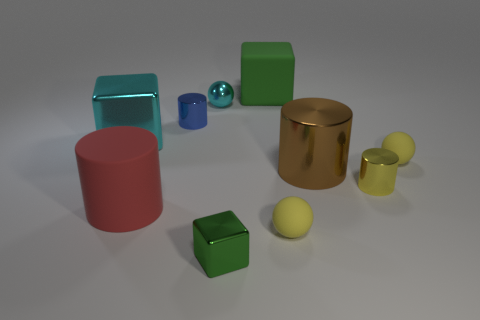Subtract all blocks. How many objects are left? 7 Subtract 0 cyan cylinders. How many objects are left? 10 Subtract all gray balls. Subtract all big matte cubes. How many objects are left? 9 Add 2 small yellow objects. How many small yellow objects are left? 5 Add 3 tiny yellow metal cubes. How many tiny yellow metal cubes exist? 3 